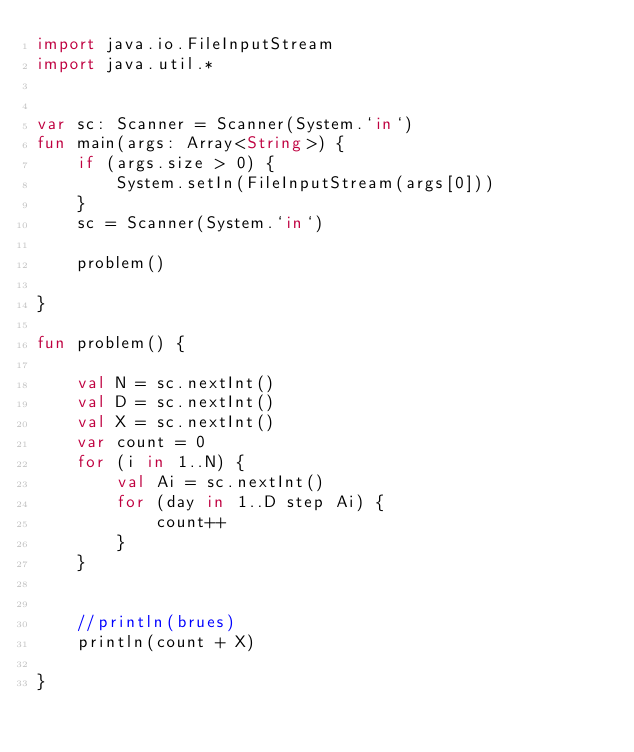<code> <loc_0><loc_0><loc_500><loc_500><_Kotlin_>import java.io.FileInputStream
import java.util.*


var sc: Scanner = Scanner(System.`in`)
fun main(args: Array<String>) {
    if (args.size > 0) {
        System.setIn(FileInputStream(args[0]))
    }
    sc = Scanner(System.`in`)

    problem()

}

fun problem() {

    val N = sc.nextInt()
    val D = sc.nextInt()
    val X = sc.nextInt()
    var count = 0
    for (i in 1..N) {
        val Ai = sc.nextInt()
        for (day in 1..D step Ai) {
            count++
        }
    }


    //println(brues)
    println(count + X)

}

</code> 